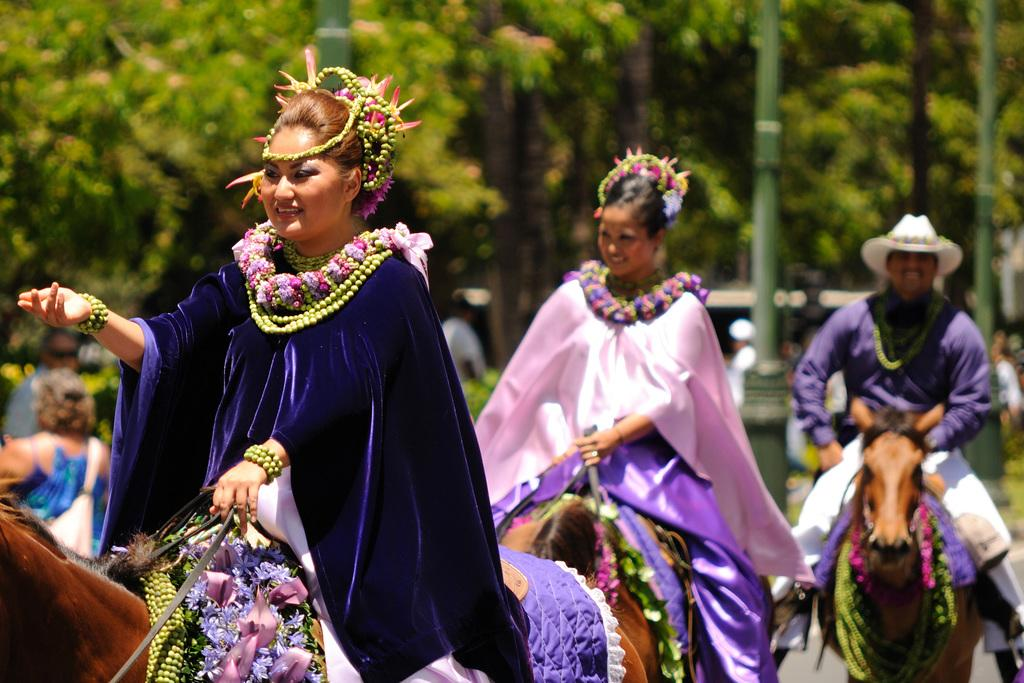What are the people in the image doing? The people in the image are riding horses. What are the people wearing while riding horses? The people are wearing jewelry. What can be seen in the background of the image? There are trees and a pole in the background of the image. What else is happening in the background of the image? There are people walking in the background of the image. How does the dust affect the railway in the image? There is no railway or dust present in the image. What type of group is depicted in the image? The image does not show a group; it shows individuals riding horses. 